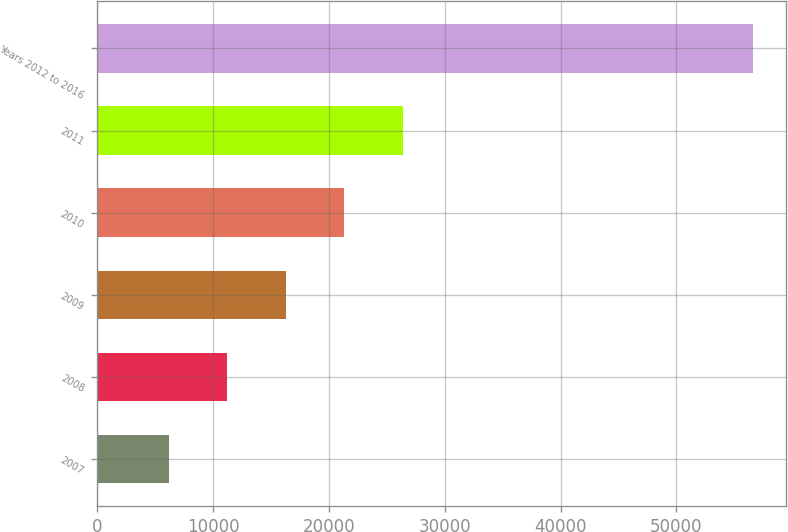<chart> <loc_0><loc_0><loc_500><loc_500><bar_chart><fcel>2007<fcel>2008<fcel>2009<fcel>2010<fcel>2011<fcel>Years 2012 to 2016<nl><fcel>6182<fcel>11225.3<fcel>16268.6<fcel>21311.9<fcel>26355.2<fcel>56615<nl></chart> 